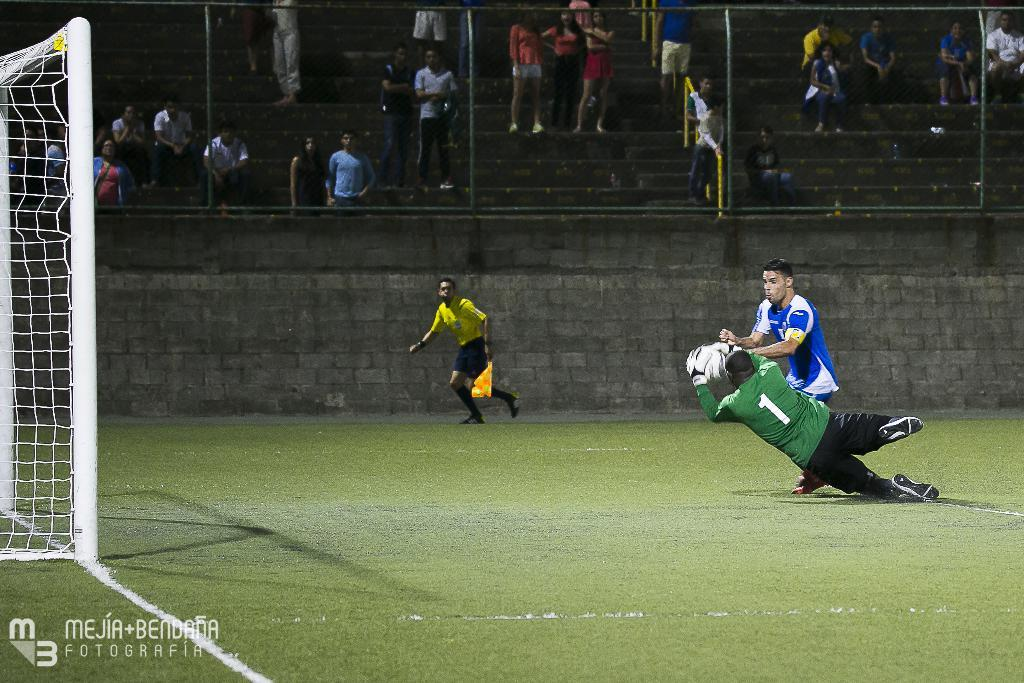<image>
Share a concise interpretation of the image provided. Number one dives and grabs the soccer ball in front of an opposing player. 